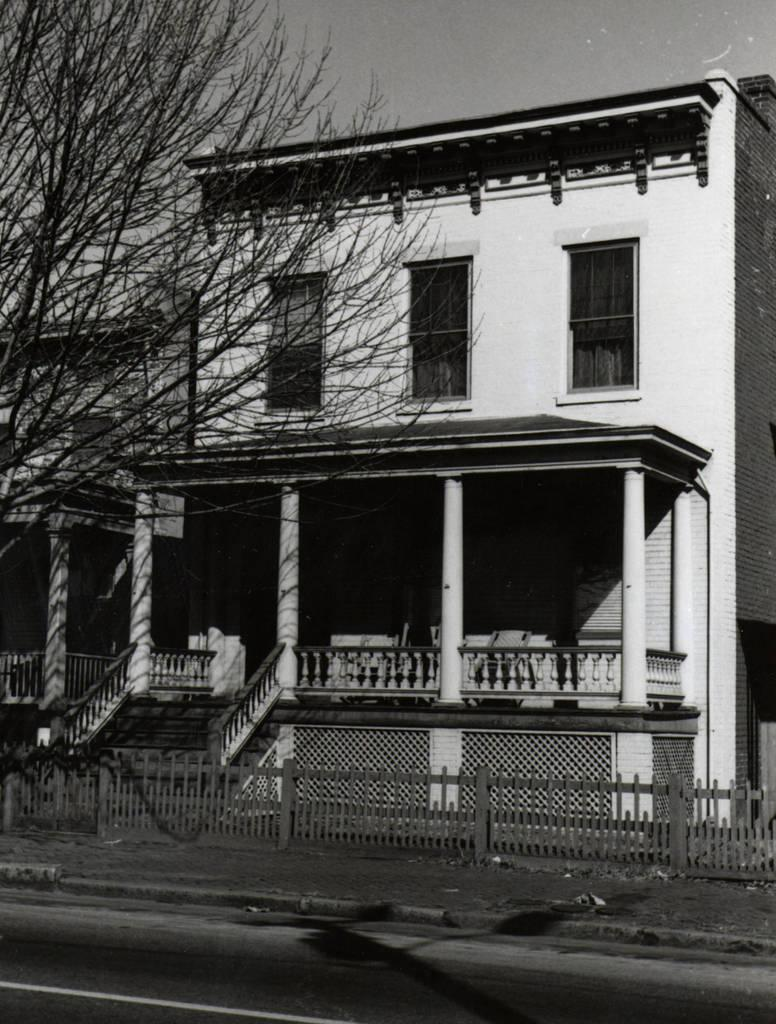What type of structures can be seen in the image? There are buildings in the image. What is located in front of the buildings? A tree and a fence are present in front of the buildings. What is the color scheme of the image? The image is in black and white. What type of sheet is covering the history in the image? There is no sheet or history present in the image; it features buildings, a tree, and a fence. What type of cup can be seen in the image? There is no cup present in the image. 